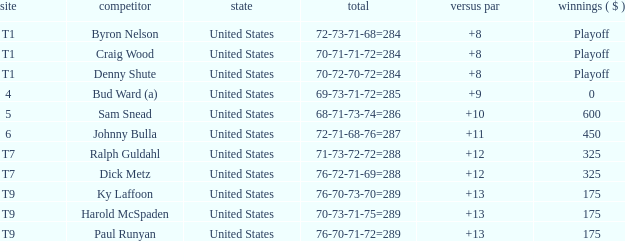What was the total To Par for Craig Wood? 8.0. 